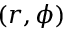Convert formula to latex. <formula><loc_0><loc_0><loc_500><loc_500>( r , \phi )</formula> 